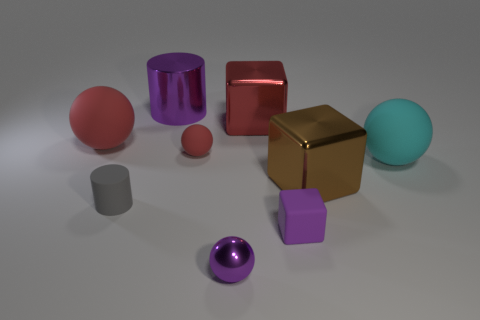Subtract all small purple cubes. How many cubes are left? 2 Add 1 metallic blocks. How many objects exist? 10 Subtract all purple balls. How many balls are left? 3 Subtract all blocks. How many objects are left? 6 Subtract all gray cubes. How many cyan balls are left? 1 Subtract all big red metal cubes. Subtract all small red balls. How many objects are left? 7 Add 2 large cubes. How many large cubes are left? 4 Add 5 tiny green metal cubes. How many tiny green metal cubes exist? 5 Subtract 0 brown cylinders. How many objects are left? 9 Subtract 2 cubes. How many cubes are left? 1 